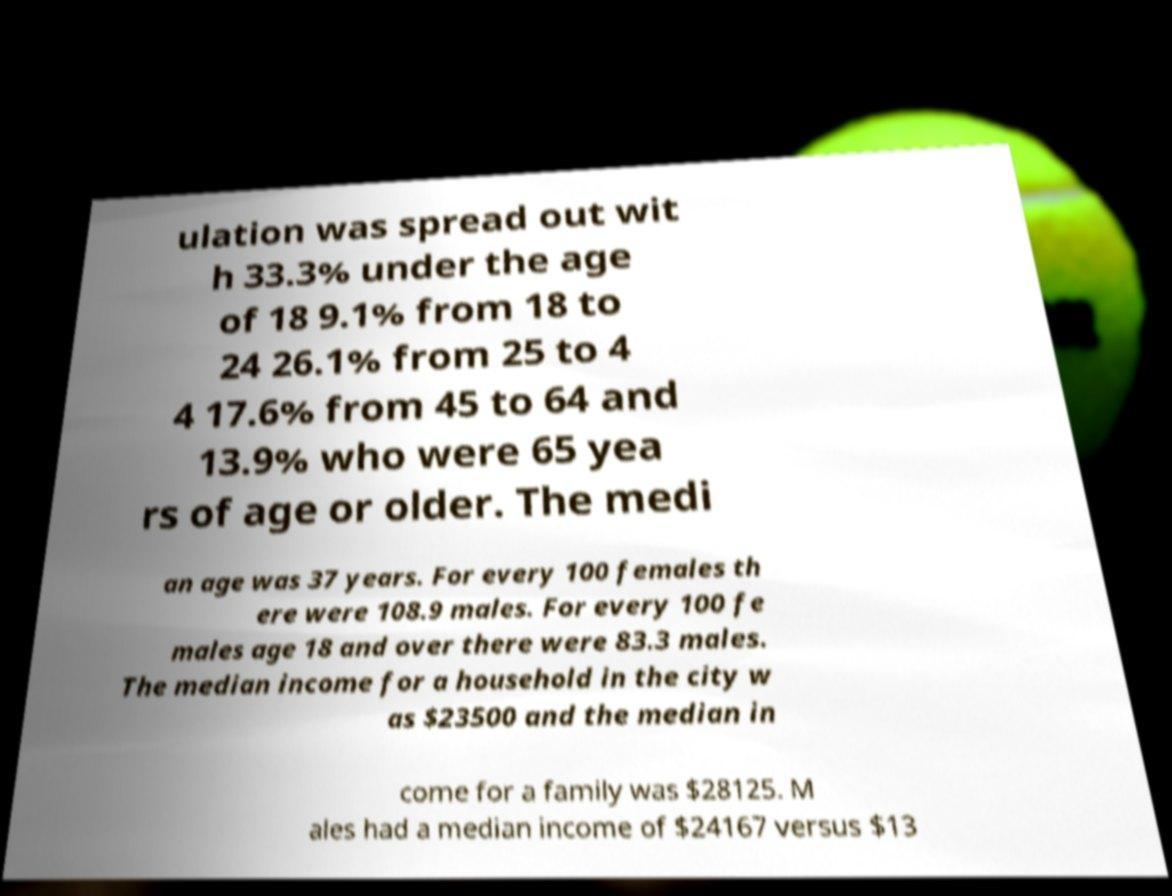Please read and relay the text visible in this image. What does it say? ulation was spread out wit h 33.3% under the age of 18 9.1% from 18 to 24 26.1% from 25 to 4 4 17.6% from 45 to 64 and 13.9% who were 65 yea rs of age or older. The medi an age was 37 years. For every 100 females th ere were 108.9 males. For every 100 fe males age 18 and over there were 83.3 males. The median income for a household in the city w as $23500 and the median in come for a family was $28125. M ales had a median income of $24167 versus $13 